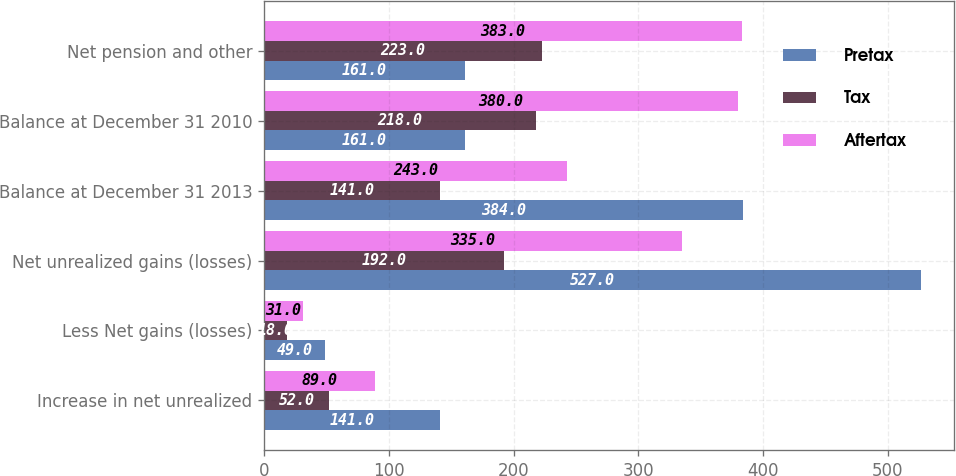Convert chart. <chart><loc_0><loc_0><loc_500><loc_500><stacked_bar_chart><ecel><fcel>Increase in net unrealized<fcel>Less Net gains (losses)<fcel>Net unrealized gains (losses)<fcel>Balance at December 31 2013<fcel>Balance at December 31 2010<fcel>Net pension and other<nl><fcel>Pretax<fcel>141<fcel>49<fcel>527<fcel>384<fcel>161<fcel>161<nl><fcel>Tax<fcel>52<fcel>18<fcel>192<fcel>141<fcel>218<fcel>223<nl><fcel>Aftertax<fcel>89<fcel>31<fcel>335<fcel>243<fcel>380<fcel>383<nl></chart> 